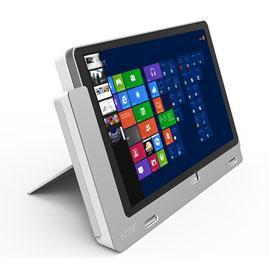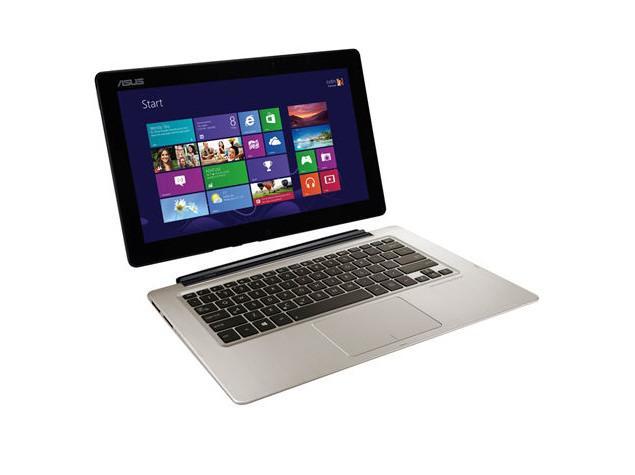The first image is the image on the left, the second image is the image on the right. Evaluate the accuracy of this statement regarding the images: "There are two computers in total.". Is it true? Answer yes or no. Yes. The first image is the image on the left, the second image is the image on the right. Given the left and right images, does the statement "A finger is pointing to an open laptop screen displaying a grid of rectangles and squares in the left image." hold true? Answer yes or no. No. 